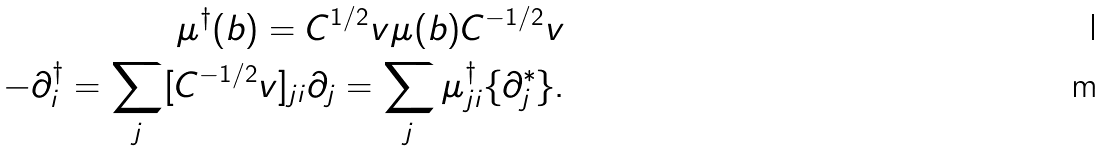<formula> <loc_0><loc_0><loc_500><loc_500>\mu ^ { \dagger } ( b ) = C ^ { 1 / 2 } _ { \ } v \mu ( b ) C ^ { - 1 / 2 } _ { \ } v \\ - \partial _ { i } ^ { \dagger } = \sum _ { j } [ C ^ { - 1 / 2 } _ { \ } v ] _ { j i } \partial _ { j } = \sum _ { j } \mu ^ { \dagger } _ { j i } \{ \partial ^ { * } _ { j } \} .</formula> 